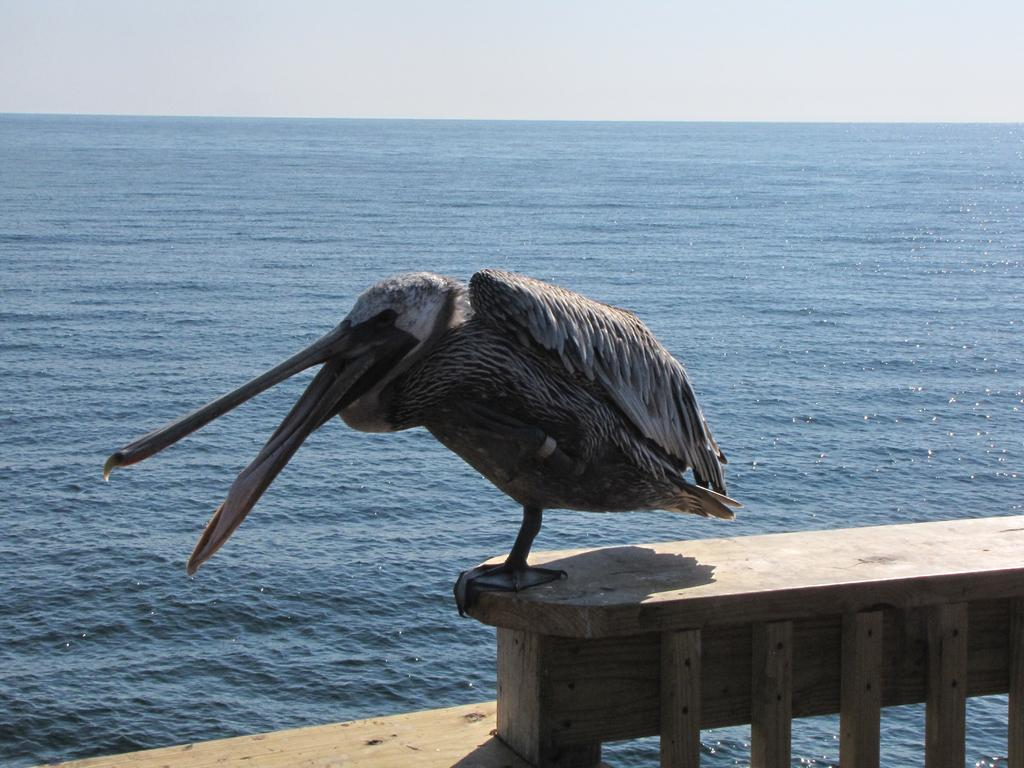What is the main subject in the center of the image? There is a bird in the center of the image. What is the bird standing on? The bird is standing on a railing. What can be seen in the background of the image? There is water in the background of the image. What is visible at the top of the image? The sky is visible at the top of the image. Where are the scissors located in the image? There are no scissors present in the image. What type of marble is visible in the image? There is no marble present in the image. 